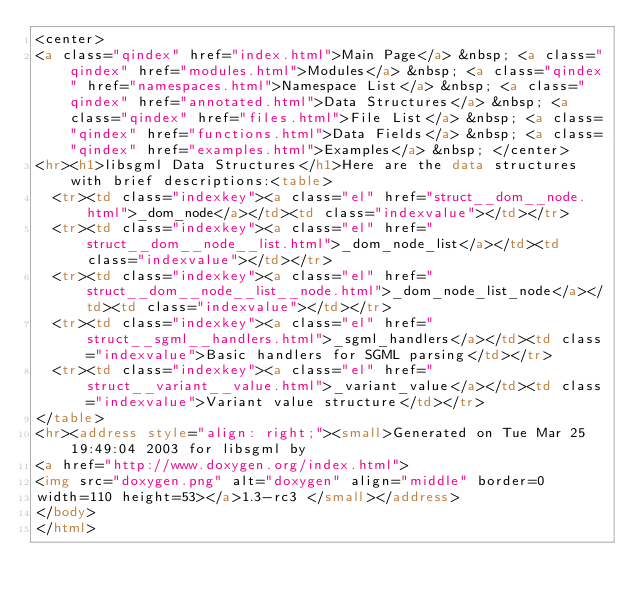Convert code to text. <code><loc_0><loc_0><loc_500><loc_500><_HTML_><center>
<a class="qindex" href="index.html">Main Page</a> &nbsp; <a class="qindex" href="modules.html">Modules</a> &nbsp; <a class="qindex" href="namespaces.html">Namespace List</a> &nbsp; <a class="qindex" href="annotated.html">Data Structures</a> &nbsp; <a class="qindex" href="files.html">File List</a> &nbsp; <a class="qindex" href="functions.html">Data Fields</a> &nbsp; <a class="qindex" href="examples.html">Examples</a> &nbsp; </center>
<hr><h1>libsgml Data Structures</h1>Here are the data structures with brief descriptions:<table>
  <tr><td class="indexkey"><a class="el" href="struct__dom__node.html">_dom_node</a></td><td class="indexvalue"></td></tr>
  <tr><td class="indexkey"><a class="el" href="struct__dom__node__list.html">_dom_node_list</a></td><td class="indexvalue"></td></tr>
  <tr><td class="indexkey"><a class="el" href="struct__dom__node__list__node.html">_dom_node_list_node</a></td><td class="indexvalue"></td></tr>
  <tr><td class="indexkey"><a class="el" href="struct__sgml__handlers.html">_sgml_handlers</a></td><td class="indexvalue">Basic handlers for SGML parsing</td></tr>
  <tr><td class="indexkey"><a class="el" href="struct__variant__value.html">_variant_value</a></td><td class="indexvalue">Variant value structure</td></tr>
</table>
<hr><address style="align: right;"><small>Generated on Tue Mar 25 19:49:04 2003 for libsgml by
<a href="http://www.doxygen.org/index.html">
<img src="doxygen.png" alt="doxygen" align="middle" border=0 
width=110 height=53></a>1.3-rc3 </small></address>
</body>
</html>
</code> 